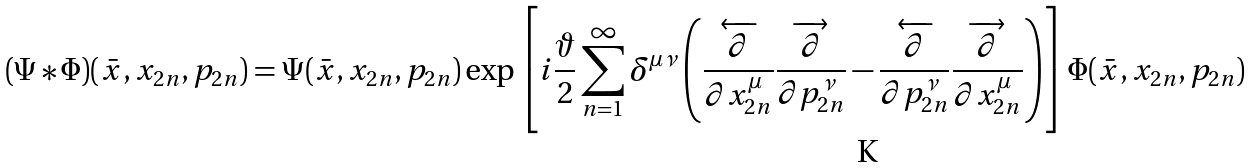<formula> <loc_0><loc_0><loc_500><loc_500>( \Psi * \Phi ) ( \bar { x } , x _ { 2 n } , p _ { 2 n } ) = \Psi ( \bar { x } , x _ { 2 n } , p _ { 2 n } ) \exp \left [ i \frac { \vartheta } { 2 } \sum ^ { \infty } _ { n = 1 } \delta ^ { \mu \nu } \left ( \frac { \overleftarrow { \partial } } { \partial x ^ { \mu } _ { 2 n } } \frac { \overrightarrow { \partial } } { \partial p ^ { \nu } _ { 2 n } } - \frac { \overleftarrow { \partial } } { \partial p ^ { \nu } _ { 2 n } } \frac { { \overrightarrow { \partial } } } { { \partial x ^ { \mu } _ { 2 n } } } \right ) \right ] \Phi ( \bar { x } , x _ { 2 n } , p _ { 2 n } )</formula> 